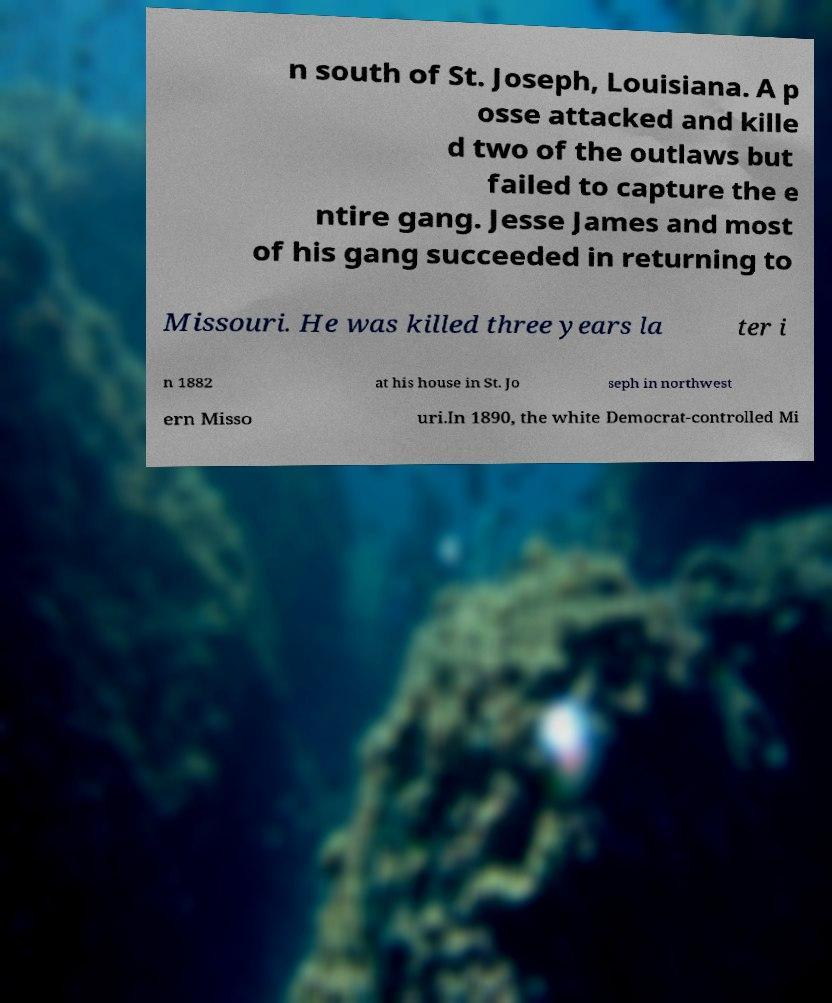Could you extract and type out the text from this image? n south of St. Joseph, Louisiana. A p osse attacked and kille d two of the outlaws but failed to capture the e ntire gang. Jesse James and most of his gang succeeded in returning to Missouri. He was killed three years la ter i n 1882 at his house in St. Jo seph in northwest ern Misso uri.In 1890, the white Democrat-controlled Mi 